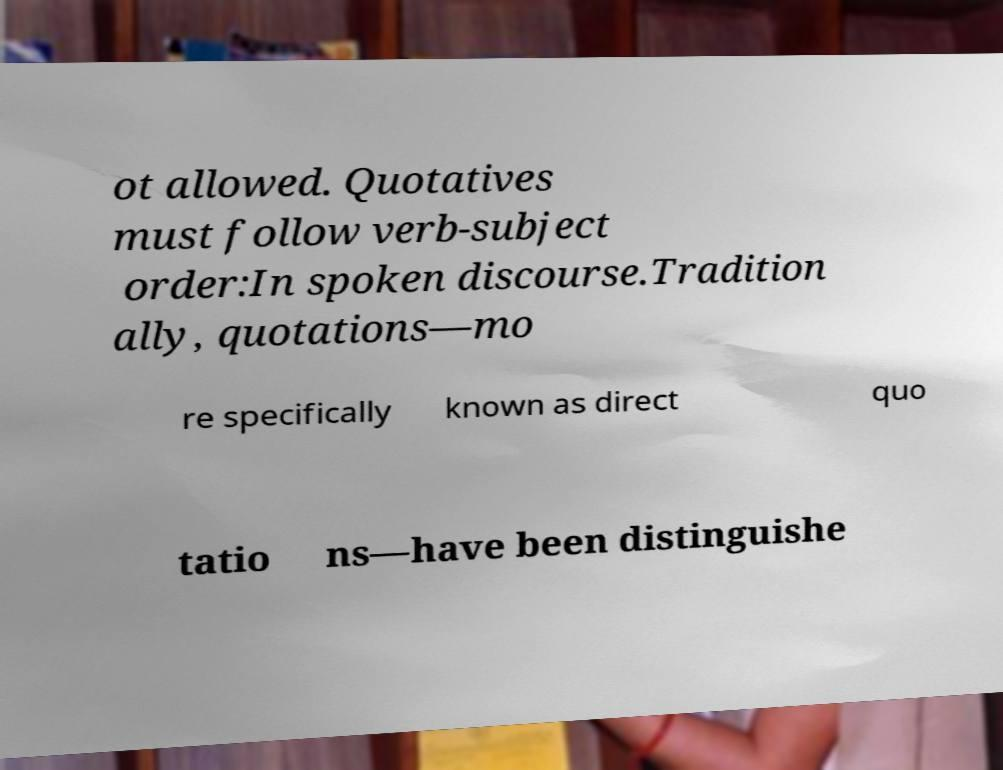Could you extract and type out the text from this image? ot allowed. Quotatives must follow verb-subject order:In spoken discourse.Tradition ally, quotations—mo re specifically known as direct quo tatio ns—have been distinguishe 